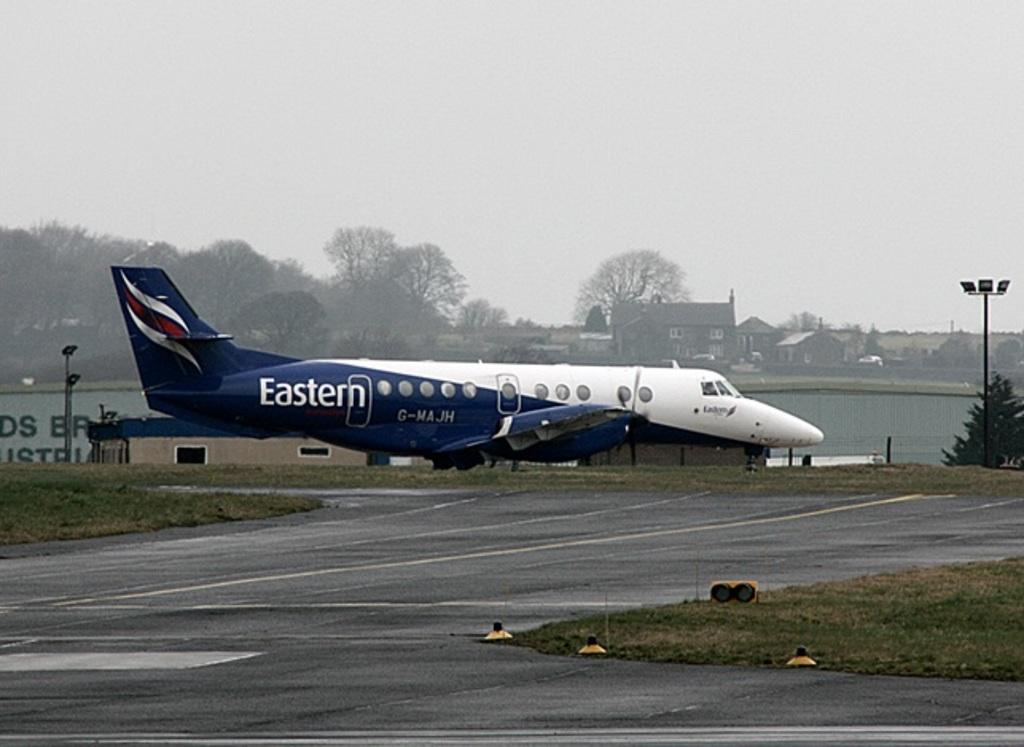What is the main subject of the image? The main subject of the image is an aeroplane. What other structures or objects can be seen in the image? There are houses, trees, poles, and roads visible in the image. What is visible in the background of the image? The sky is visible in the background of the image. How much sugar is being requested by the tramp in the image? There is no tramp present in the image, and therefore no such request can be observed. 